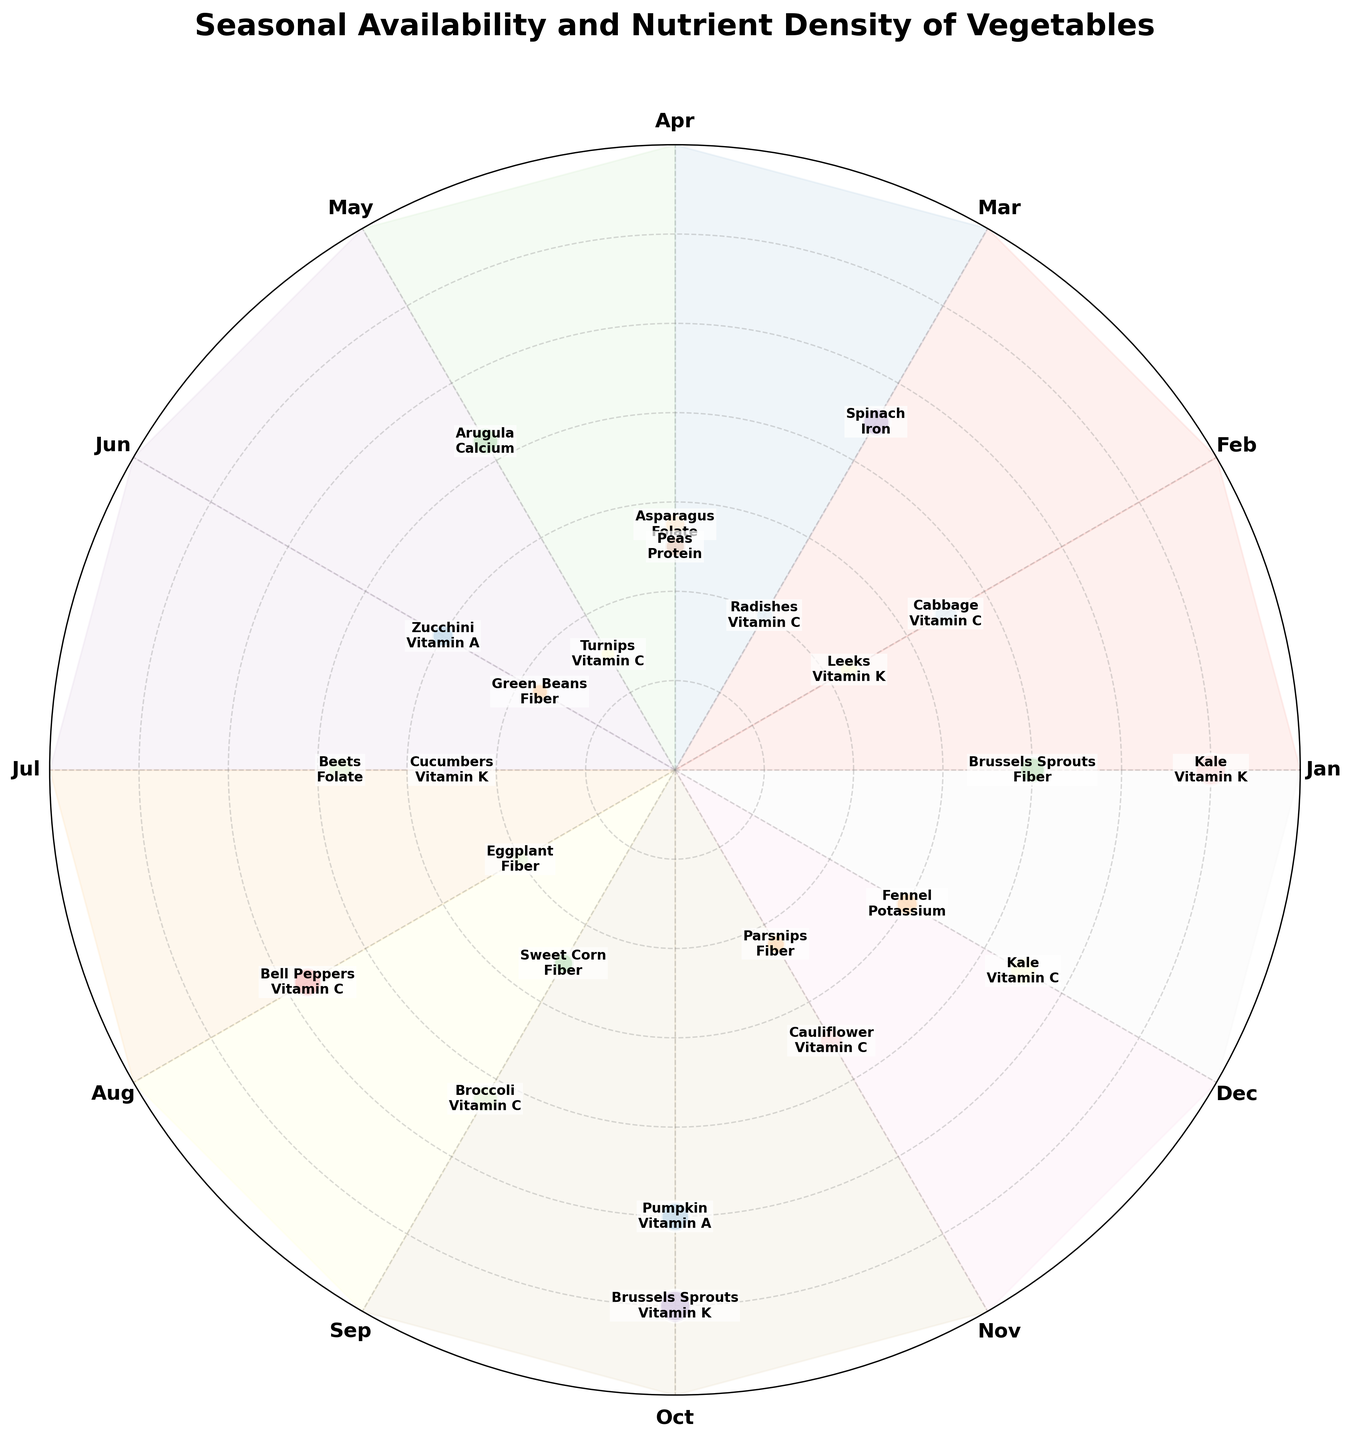What is the title of the figure? The title is displayed prominently at the top of the plot in larger and bold text. It gives a summary of what the plot represents.
Answer: Seasonal Availability and Nutrient Density of Vegetables Which vegetable has the highest nutrient density in the figure? By observing the radial (y-axis) values, the highest density is noted by the vegetable located furthest from the center. The Brussels Sprouts in both January and October have the highest readings at a value of 120.
Answer: Brussels Sprouts What vegetable is high in Vitamin C in August? Locate the data points for August and check the labels denoting "Vitamin C". The Bell Peppers are listed with this attribute.
Answer: Bell Peppers In which month is kale available, and which nutrients does it provide? Look for the labeling of 'Kale' around the monthly plot; it appears in January and December, providing Vitamin K and Vitamin C, respectively.
Answer: January (Vitamin K) and December (Vitamin C) Which month has the most data points for different vegetables? To answer, count the number of data points or vegetables for each month depicted around the circle. January has two points for Kale and Brussels Sprouts, and November also has two for Cauliflower and Parsnips, having the highest.
Answer: January and November Which vegetable providing Vitamin A is available in October? Identify the labels mentioning "Vitamin A" in October on the polar chart. The Pumpkin is marked with this nutrient.
Answer: Pumpkin Compare the nutrient densities of Kale in January and December; which month has higher density? Check the radial distances for Kale in both months. January shows a density of 120 and December shows 90. Hence, January has higher nutrient density.
Answer: January What is the average nutrient density of vegetables available in February? In February, observe the values for Cabbage (70) and Leeks (45). Calculate the average by summing them (70 + 45 = 115) and dividing by the count (115 / 2).
Answer: 57.5 Which months have vegetables that provide Folate, and what are their nutrient densities? Look for the labels indicating "Folate" and note their corresponding months and densities. Asparagus in April (55) and Beets in July (75) have Folate.
Answer: April (55) and July (75) How many vegetables provide Vitamin C across all months? Count the labels mentioning "Vitamin C" throughout the figure. There are five: Cabbage (Feb), Radishes (Mar), Turnips (May), Bell Peppers (Aug), Broccoli (Sep), and Kale (Dec).
Answer: Six 